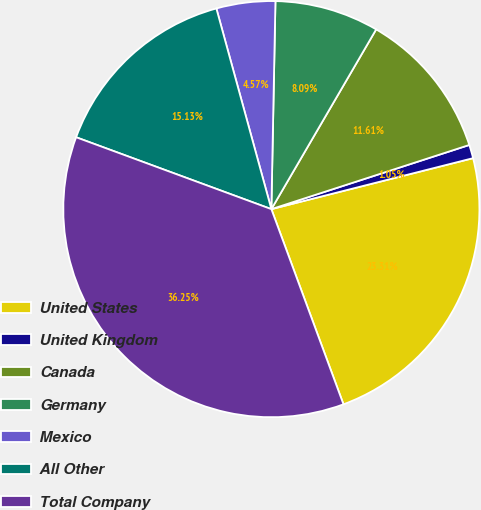Convert chart to OTSL. <chart><loc_0><loc_0><loc_500><loc_500><pie_chart><fcel>United States<fcel>United Kingdom<fcel>Canada<fcel>Germany<fcel>Mexico<fcel>All Other<fcel>Total Company<nl><fcel>23.31%<fcel>1.05%<fcel>11.61%<fcel>8.09%<fcel>4.57%<fcel>15.13%<fcel>36.25%<nl></chart> 